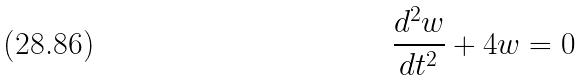Convert formula to latex. <formula><loc_0><loc_0><loc_500><loc_500>\frac { d ^ { 2 } w } { d t ^ { 2 } } + 4 w = 0</formula> 